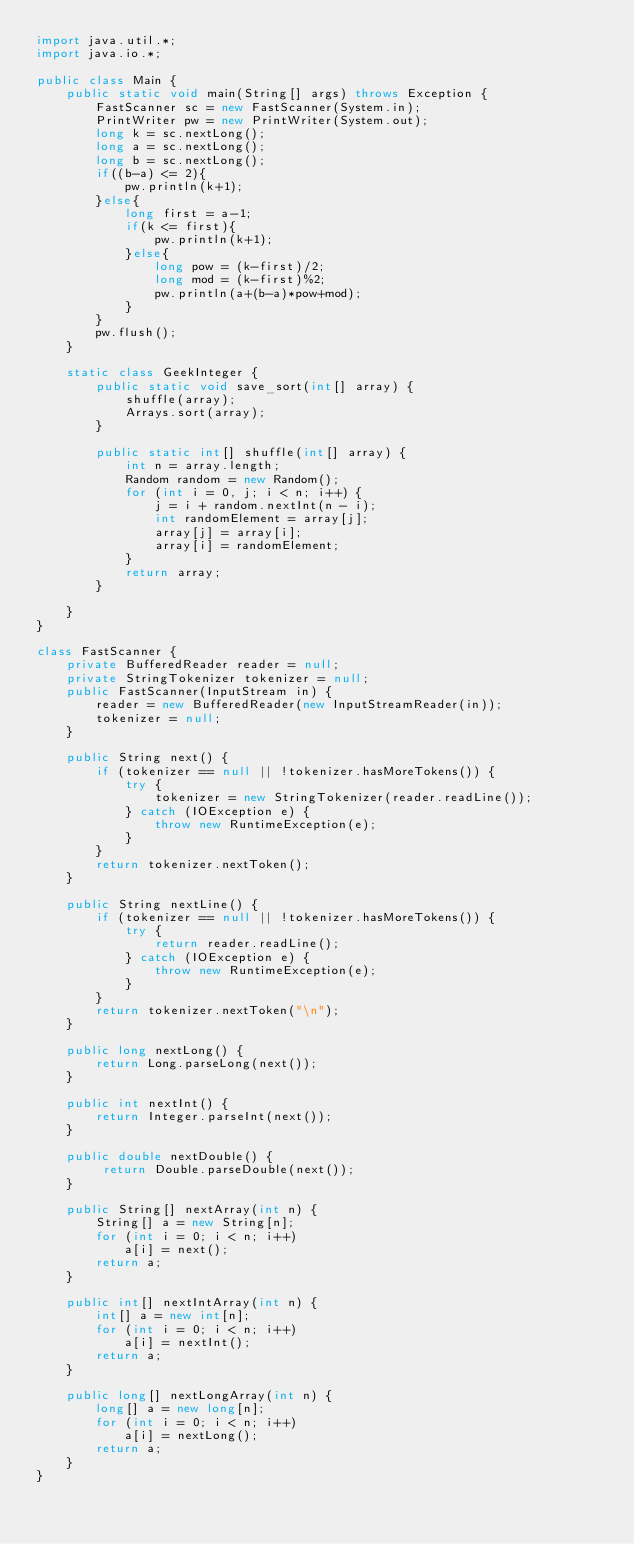<code> <loc_0><loc_0><loc_500><loc_500><_Java_>import java.util.*;
import java.io.*;
 
public class Main {
    public static void main(String[] args) throws Exception {
        FastScanner sc = new FastScanner(System.in);
        PrintWriter pw = new PrintWriter(System.out);
        long k = sc.nextLong();
        long a = sc.nextLong();
        long b = sc.nextLong();
        if((b-a) <= 2){
            pw.println(k+1);
        }else{
            long first = a-1;
            if(k <= first){
                pw.println(k+1);
            }else{
                long pow = (k-first)/2;
                long mod = (k-first)%2;
                pw.println(a+(b-a)*pow+mod);
            }
        }
        pw.flush();
    }

    static class GeekInteger {
        public static void save_sort(int[] array) {
            shuffle(array);
            Arrays.sort(array);
        }
 
        public static int[] shuffle(int[] array) {
            int n = array.length;
            Random random = new Random();
            for (int i = 0, j; i < n; i++) {
                j = i + random.nextInt(n - i);
                int randomElement = array[j];
                array[j] = array[i];
                array[i] = randomElement;
            }
            return array;
        }
 
    }
}

class FastScanner {
    private BufferedReader reader = null;
    private StringTokenizer tokenizer = null;
    public FastScanner(InputStream in) {
        reader = new BufferedReader(new InputStreamReader(in));
        tokenizer = null;
    }

    public String next() {
        if (tokenizer == null || !tokenizer.hasMoreTokens()) {
            try {
                tokenizer = new StringTokenizer(reader.readLine());
            } catch (IOException e) {
                throw new RuntimeException(e);
            }
        }
        return tokenizer.nextToken();
    }

    public String nextLine() {
        if (tokenizer == null || !tokenizer.hasMoreTokens()) {
            try {
                return reader.readLine();
            } catch (IOException e) {
                throw new RuntimeException(e);
            }
        }
        return tokenizer.nextToken("\n");
    }

    public long nextLong() {
        return Long.parseLong(next());
    }

    public int nextInt() {
        return Integer.parseInt(next());
    }

    public double nextDouble() {
         return Double.parseDouble(next());
    }
    
    public String[] nextArray(int n) {
        String[] a = new String[n];
        for (int i = 0; i < n; i++)
            a[i] = next();
        return a;
    }

    public int[] nextIntArray(int n) {
        int[] a = new int[n];
        for (int i = 0; i < n; i++)
            a[i] = nextInt();
        return a;
    }

    public long[] nextLongArray(int n) {
        long[] a = new long[n];
        for (int i = 0; i < n; i++)
            a[i] = nextLong();
        return a;
    } 
}
</code> 